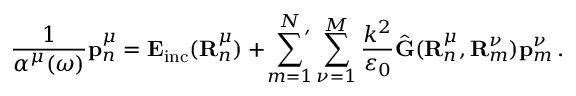<formula> <loc_0><loc_0><loc_500><loc_500>\frac { 1 } { \alpha ^ { \mu } ( \omega ) } p _ { n } ^ { \mu } = E _ { i n c } ( R _ { n } ^ { \mu } ) + { ^ { \prime } } \sum _ { m = 1 } ^ { N } \sum _ { \nu = 1 } ^ { M } \frac { k ^ { 2 } } { \varepsilon _ { 0 } } \hat { G } ( R _ { n } ^ { \mu } , R _ { m } ^ { \nu } ) p _ { m } ^ { \nu } \, .</formula> 